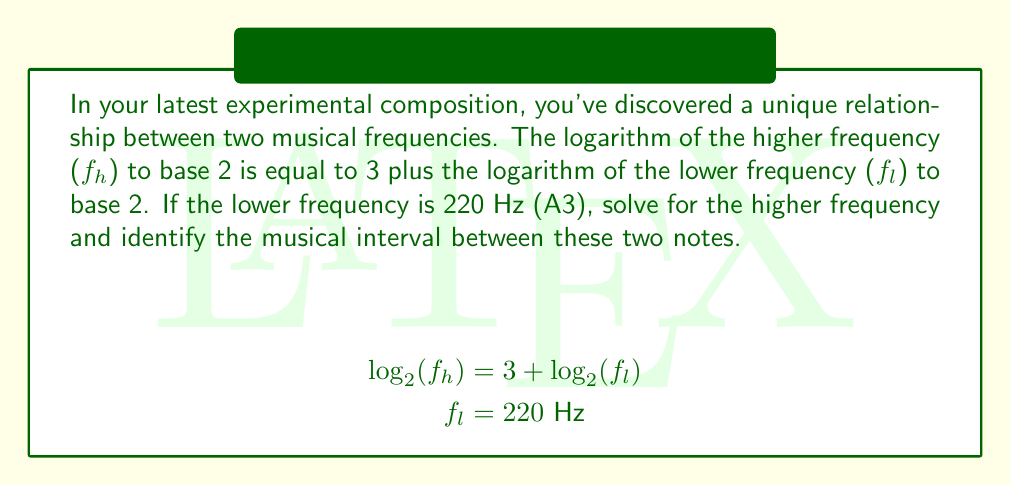Teach me how to tackle this problem. Let's solve this step-by-step:

1) We're given the equation: $\log_2(f_h) = 3 + \log_2(f_l)$

2) We know that $f_l = 220$ Hz. Let's substitute this:
   $\log_2(f_h) = 3 + \log_2(220)$

3) To solve for $f_h$, we need to apply the inverse function (exponential) to both sides:
   $2^{\log_2(f_h)} = 2^{3 + \log_2(220)}$

4) The left side simplifies to $f_h$:
   $f_h = 2^{3 + \log_2(220)}$

5) Using the laws of exponents, we can rewrite this as:
   $f_h = 2^3 \cdot 2^{\log_2(220)}$

6) $2^{\log_2(220)}$ simplifies to 220:
   $f_h = 2^3 \cdot 220$

7) Calculate:
   $f_h = 8 \cdot 220 = 1760$ Hz

8) To identify the interval, we need to find the ratio of the frequencies:
   $\frac{f_h}{f_l} = \frac{1760}{220} = 8$

9) A frequency ratio of 8:1 corresponds to a musical interval of 3 octaves.
Answer: $f_h = 1760$ Hz; Interval: 3 octaves 